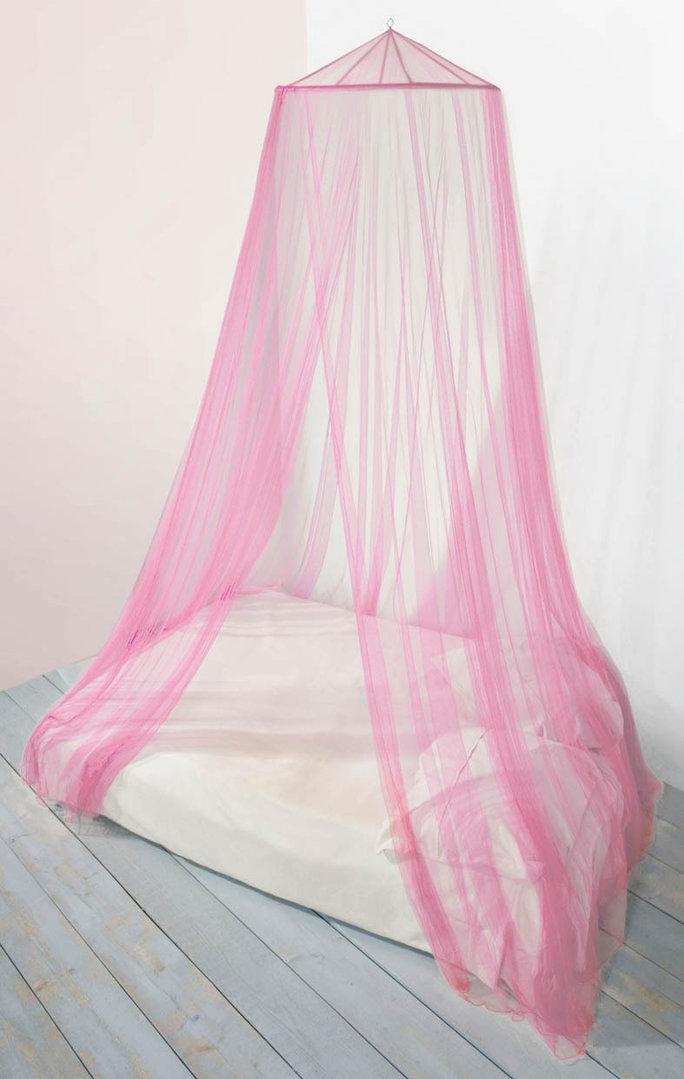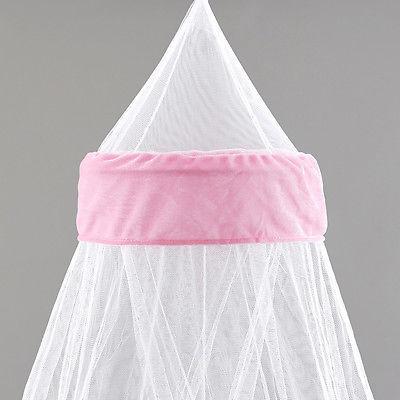The first image is the image on the left, the second image is the image on the right. Assess this claim about the two images: "Only two pillows are visible ont he right image.". Correct or not? Answer yes or no. No. 